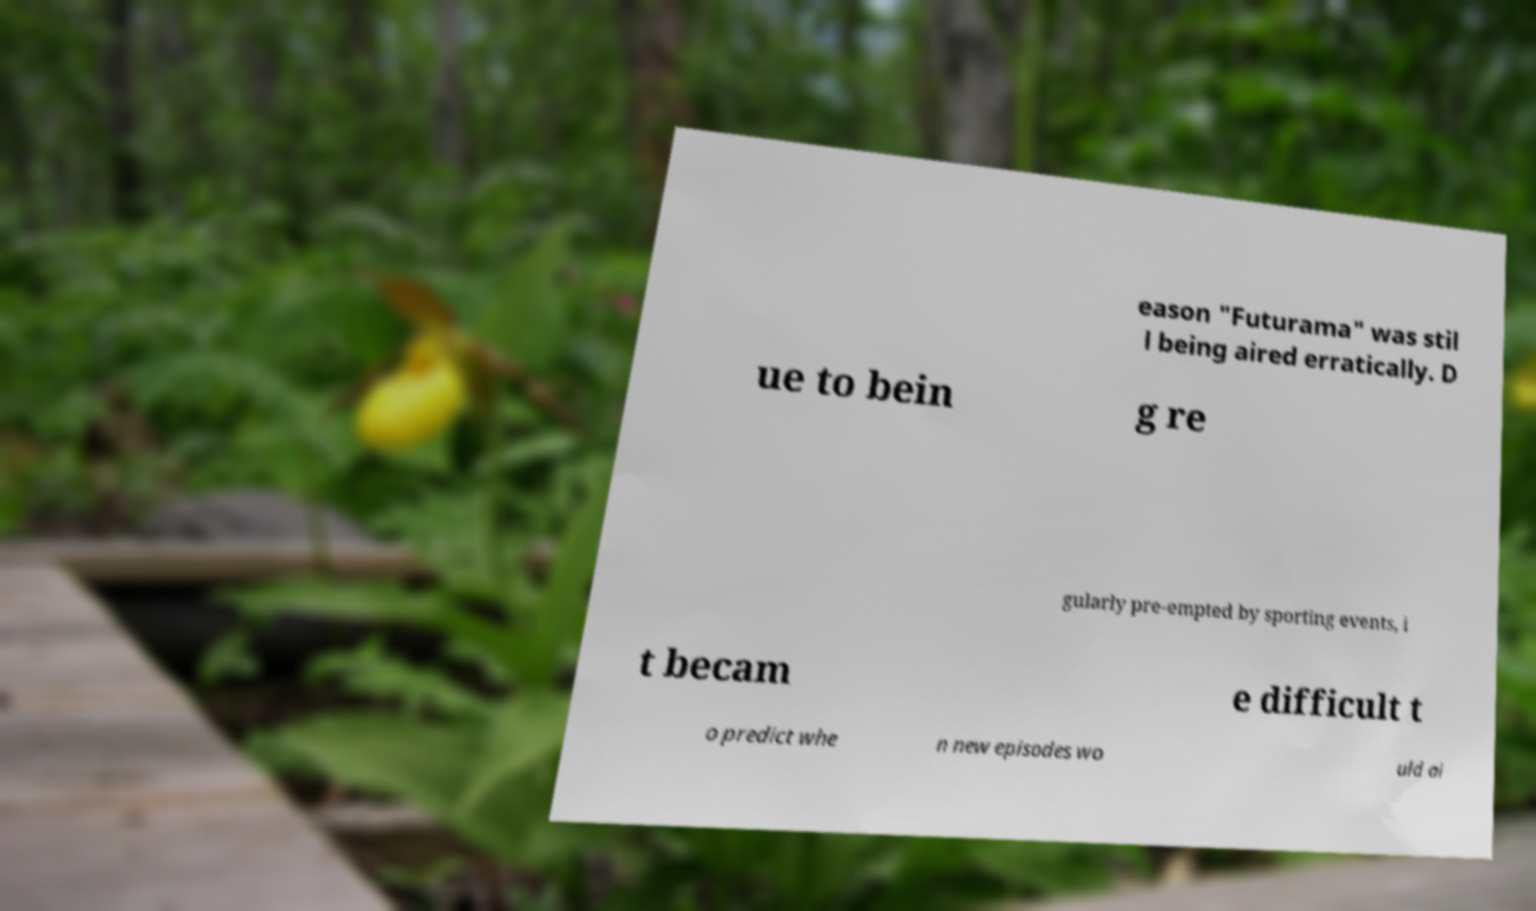Please identify and transcribe the text found in this image. eason "Futurama" was stil l being aired erratically. D ue to bein g re gularly pre-empted by sporting events, i t becam e difficult t o predict whe n new episodes wo uld ai 